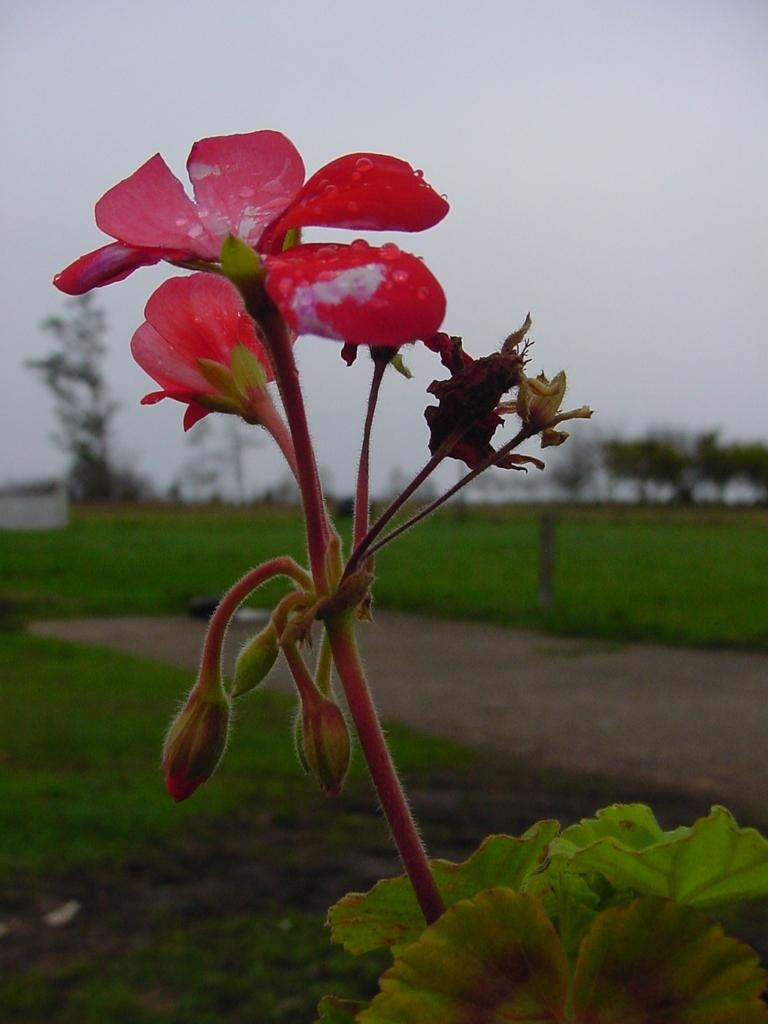What type of flower is in the image? There is a red flower in the image. Can you describe the flower's structure? The flower has a stem and leaves. What type of vegetation is visible in the image besides the flower? There is grass visible in the image. What else can be seen in the background of the image? There are trees present in the image? What is visible at the top of the image? The sky is visible in the image. What statement is being made by the map in the image? There is no map present in the image, so no statement can be made by a map. 